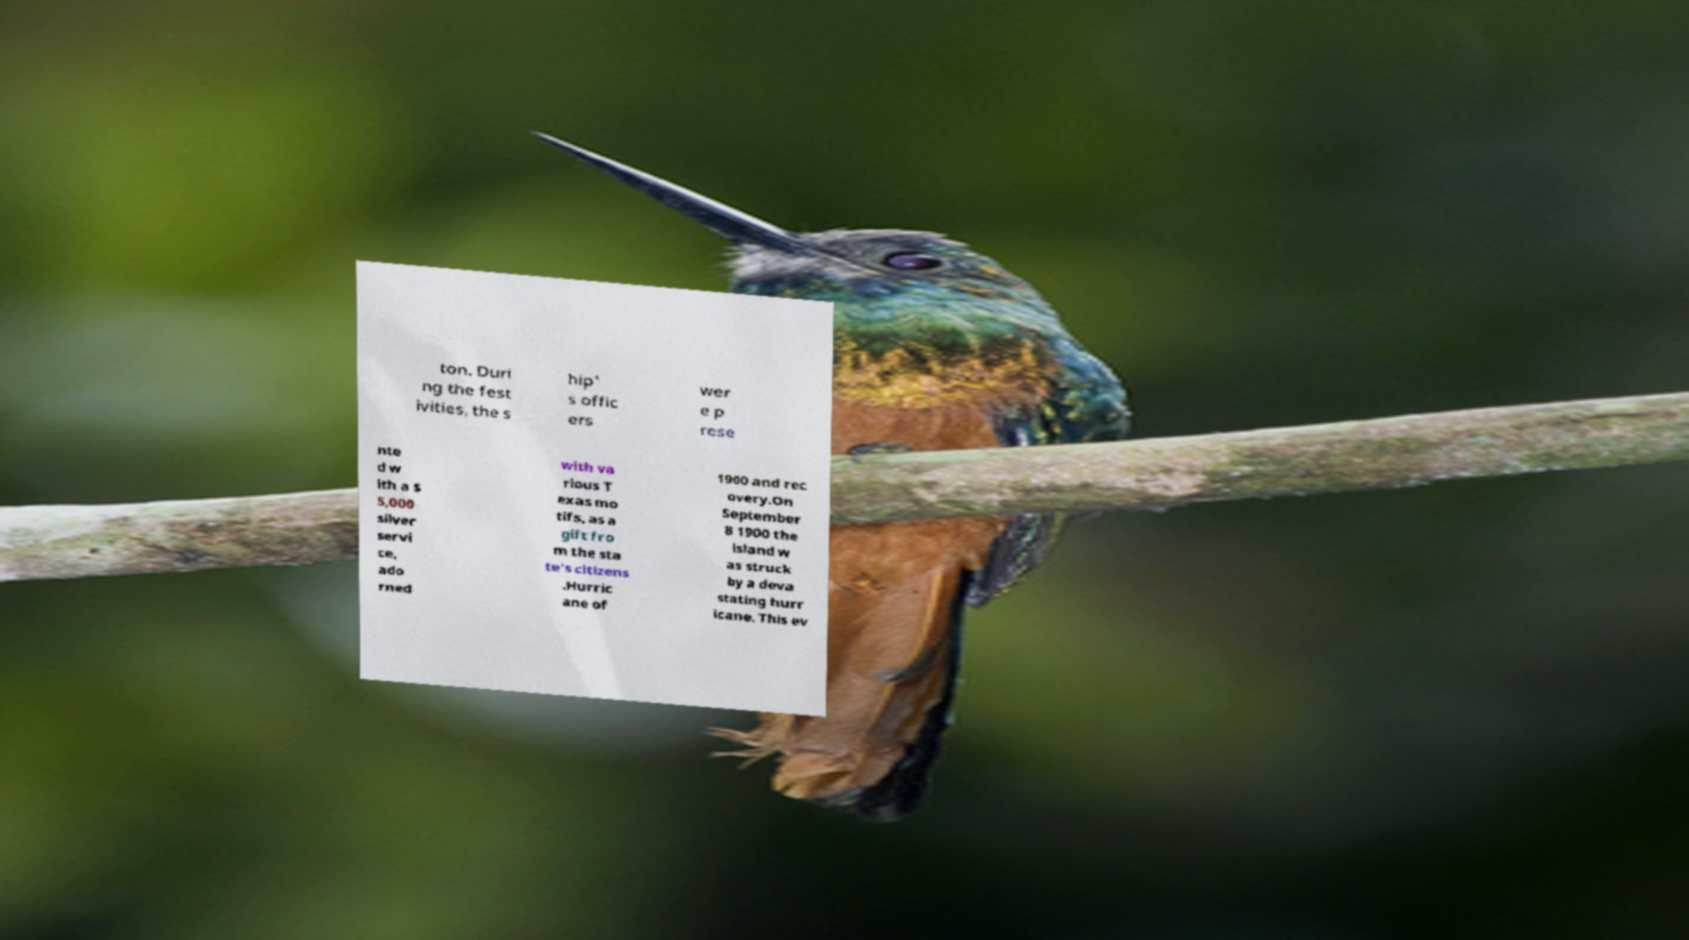Please identify and transcribe the text found in this image. ton. Duri ng the fest ivities, the s hip' s offic ers wer e p rese nte d w ith a $ 5,000 silver servi ce, ado rned with va rious T exas mo tifs, as a gift fro m the sta te's citizens .Hurric ane of 1900 and rec overy.On September 8 1900 the island w as struck by a deva stating hurr icane. This ev 